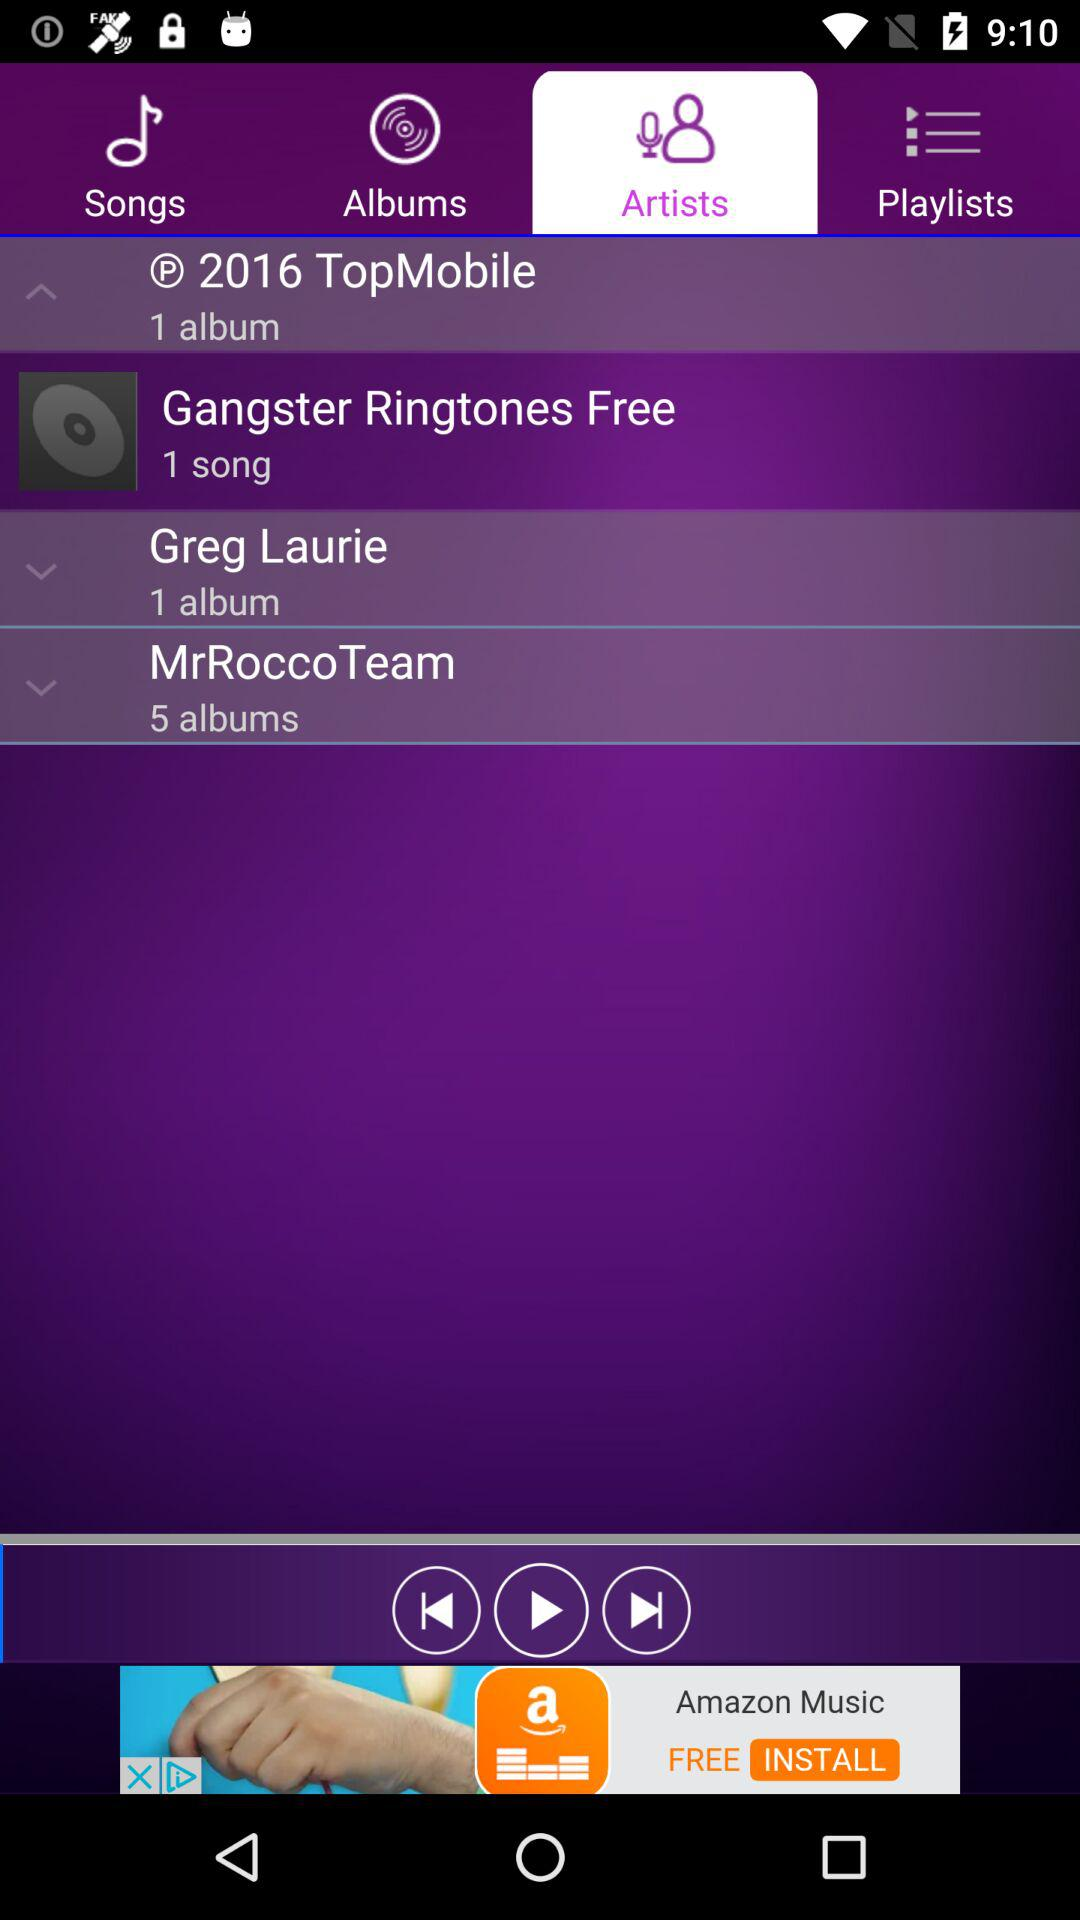How many albums are there by Greg Laurie? There is 1 album by Greg Laurie. 